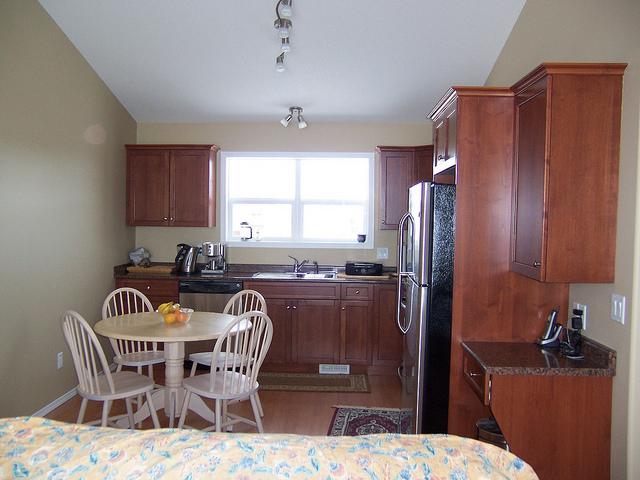How many windows are there?
Quick response, please. 1. Where is the phone?
Short answer required. Counter. How many chairs are at the table?
Answer briefly. 4. 